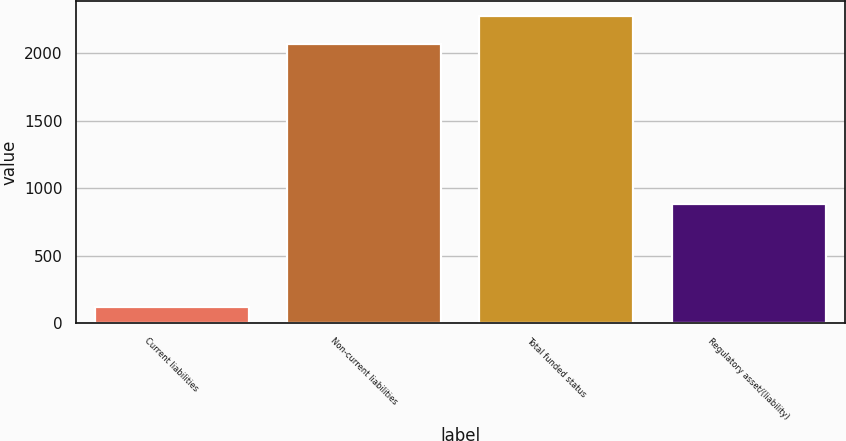Convert chart. <chart><loc_0><loc_0><loc_500><loc_500><bar_chart><fcel>Current liabilities<fcel>Non-current liabilities<fcel>Total funded status<fcel>Regulatory asset/(liability)<nl><fcel>119<fcel>2066<fcel>2272.6<fcel>883<nl></chart> 